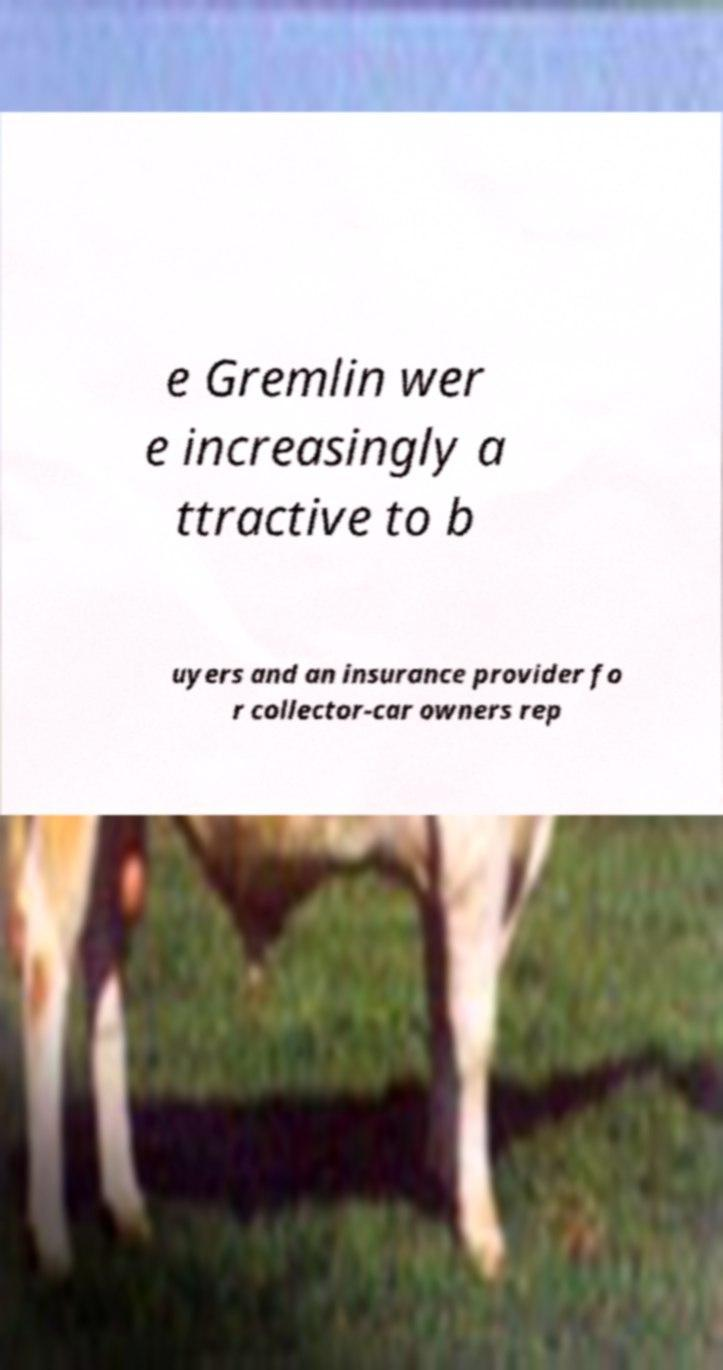Could you assist in decoding the text presented in this image and type it out clearly? e Gremlin wer e increasingly a ttractive to b uyers and an insurance provider fo r collector-car owners rep 